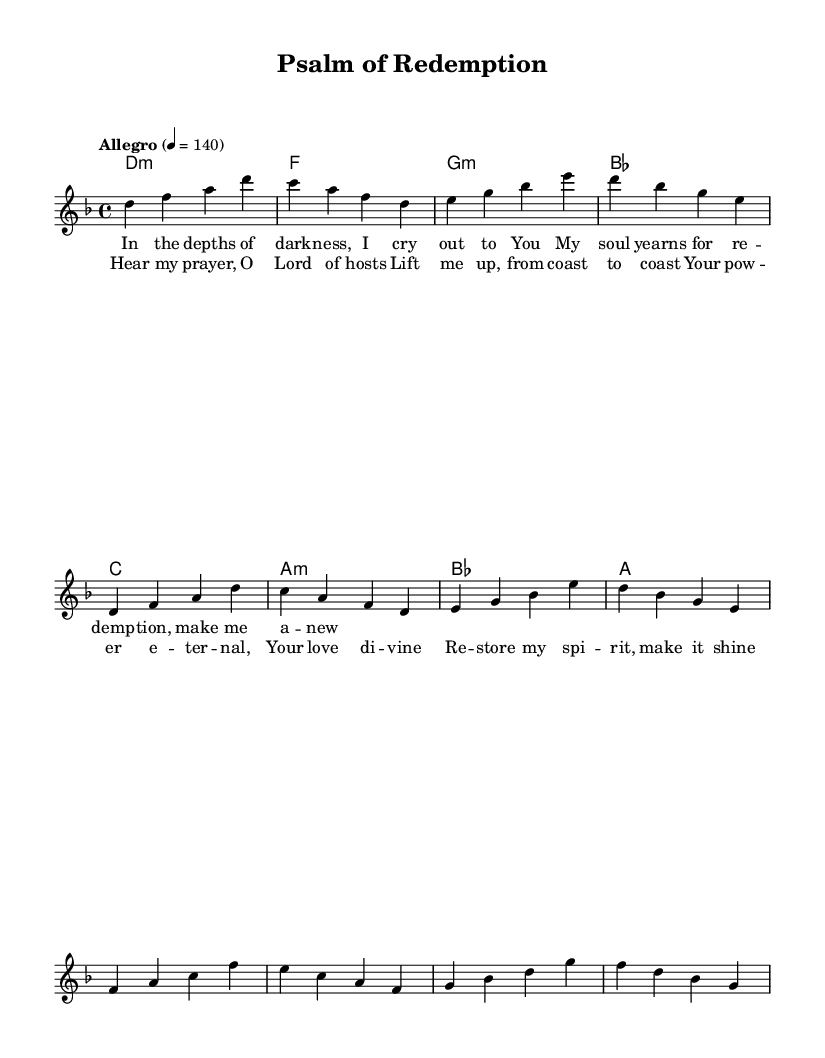What is the key signature of this music? The key signature is D minor, which has one flat (B flat). This can be identified by looking at the key signature at the beginning of the staff.
Answer: D minor What is the time signature of this piece? The time signature is 4/4, indicated at the beginning of the sheet music. It signifies that there are four beats per measure and the quarter note gets the beat.
Answer: 4/4 What is the tempo marking for this composition? The tempo marking is "Allegro" with a metronome marking of 140 beats per minute, which means it should be played at a fast and lively pace. This is mentioned in the global settings of the music.
Answer: 140 What is the title of this piece? The title of the piece is "Psalm of Redemption" and is stated at the top of the sheet music. This title likely reflects the thematic content of the music, possibly drawing on Christian themes.
Answer: Psalm of Redemption How many verses are present in the song structure? There is one verse indicated in the sheet music, as there is a single lyrical section labeled as "verse" before the chorus, which suggests the piece follows a verse-chorus structure common in many songs.
Answer: One What choral arrangement technique is used in this symphonic metal piece? The piece incorporates choral arrangements of hymns and psalms, as evident in the lyrical content which draws on themes of redemption and prayer, typical of such arrangements. This integrates musical elements with religious themes.
Answer: Choral arrangements What is the main theme described in the lyrics? The main theme described in the lyrics revolves around seeking redemption and divine assistance, as reflected in phrases about crying out to God and yearning for restoration, which is indicative of Christian faith and practice.
Answer: Redemption 